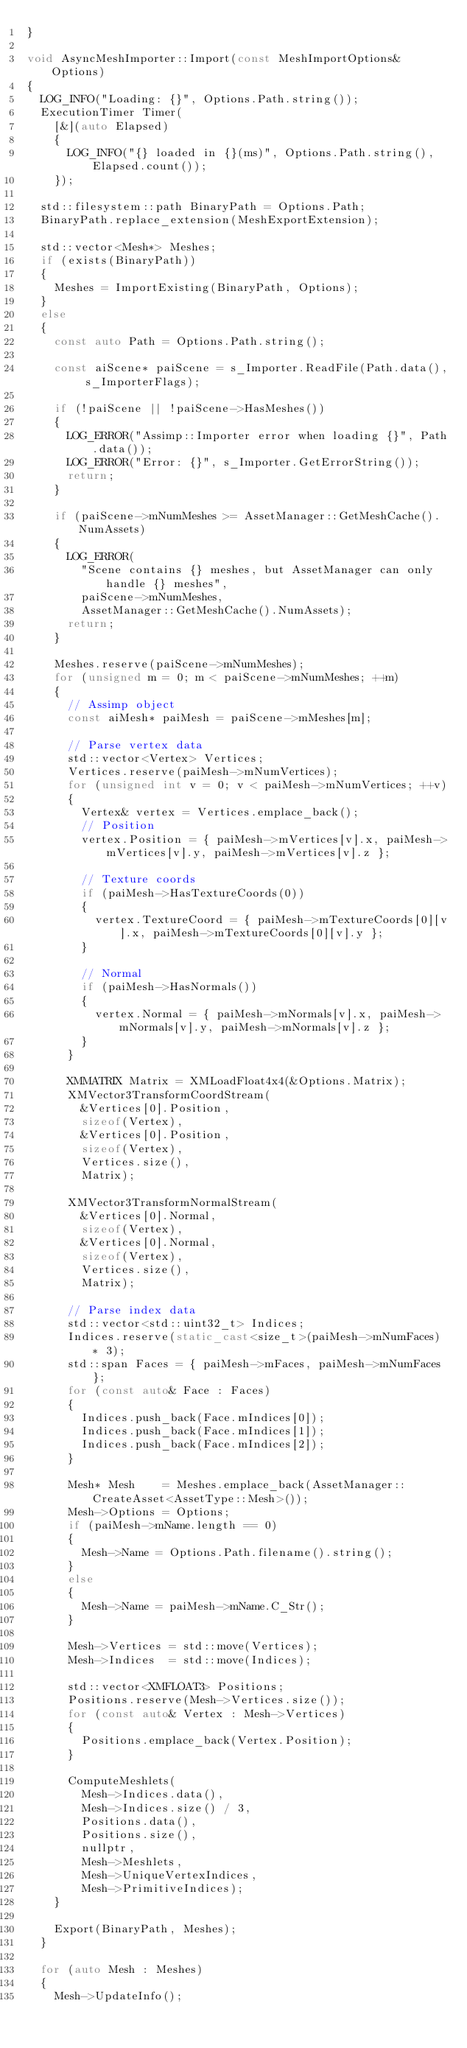<code> <loc_0><loc_0><loc_500><loc_500><_C++_>}

void AsyncMeshImporter::Import(const MeshImportOptions& Options)
{
	LOG_INFO("Loading: {}", Options.Path.string());
	ExecutionTimer Timer(
		[&](auto Elapsed)
		{
			LOG_INFO("{} loaded in {}(ms)", Options.Path.string(), Elapsed.count());
		});

	std::filesystem::path BinaryPath = Options.Path;
	BinaryPath.replace_extension(MeshExportExtension);

	std::vector<Mesh*> Meshes;
	if (exists(BinaryPath))
	{
		Meshes = ImportExisting(BinaryPath, Options);
	}
	else
	{
		const auto Path = Options.Path.string();

		const aiScene* paiScene = s_Importer.ReadFile(Path.data(), s_ImporterFlags);

		if (!paiScene || !paiScene->HasMeshes())
		{
			LOG_ERROR("Assimp::Importer error when loading {}", Path.data());
			LOG_ERROR("Error: {}", s_Importer.GetErrorString());
			return;
		}

		if (paiScene->mNumMeshes >= AssetManager::GetMeshCache().NumAssets)
		{
			LOG_ERROR(
				"Scene contains {} meshes, but AssetManager can only handle {} meshes",
				paiScene->mNumMeshes,
				AssetManager::GetMeshCache().NumAssets);
			return;
		}

		Meshes.reserve(paiScene->mNumMeshes);
		for (unsigned m = 0; m < paiScene->mNumMeshes; ++m)
		{
			// Assimp object
			const aiMesh* paiMesh = paiScene->mMeshes[m];

			// Parse vertex data
			std::vector<Vertex> Vertices;
			Vertices.reserve(paiMesh->mNumVertices);
			for (unsigned int v = 0; v < paiMesh->mNumVertices; ++v)
			{
				Vertex& vertex = Vertices.emplace_back();
				// Position
				vertex.Position = { paiMesh->mVertices[v].x, paiMesh->mVertices[v].y, paiMesh->mVertices[v].z };

				// Texture coords
				if (paiMesh->HasTextureCoords(0))
				{
					vertex.TextureCoord = { paiMesh->mTextureCoords[0][v].x, paiMesh->mTextureCoords[0][v].y };
				}

				// Normal
				if (paiMesh->HasNormals())
				{
					vertex.Normal = { paiMesh->mNormals[v].x, paiMesh->mNormals[v].y, paiMesh->mNormals[v].z };
				}
			}

			XMMATRIX Matrix = XMLoadFloat4x4(&Options.Matrix);
			XMVector3TransformCoordStream(
				&Vertices[0].Position,
				sizeof(Vertex),
				&Vertices[0].Position,
				sizeof(Vertex),
				Vertices.size(),
				Matrix);

			XMVector3TransformNormalStream(
				&Vertices[0].Normal,
				sizeof(Vertex),
				&Vertices[0].Normal,
				sizeof(Vertex),
				Vertices.size(),
				Matrix);

			// Parse index data
			std::vector<std::uint32_t> Indices;
			Indices.reserve(static_cast<size_t>(paiMesh->mNumFaces) * 3);
			std::span Faces = { paiMesh->mFaces, paiMesh->mNumFaces };
			for (const auto& Face : Faces)
			{
				Indices.push_back(Face.mIndices[0]);
				Indices.push_back(Face.mIndices[1]);
				Indices.push_back(Face.mIndices[2]);
			}

			Mesh* Mesh	  = Meshes.emplace_back(AssetManager::CreateAsset<AssetType::Mesh>());
			Mesh->Options = Options;
			if (paiMesh->mName.length == 0)
			{
				Mesh->Name = Options.Path.filename().string();
			}
			else
			{
				Mesh->Name = paiMesh->mName.C_Str();
			}

			Mesh->Vertices = std::move(Vertices);
			Mesh->Indices  = std::move(Indices);

			std::vector<XMFLOAT3> Positions;
			Positions.reserve(Mesh->Vertices.size());
			for (const auto& Vertex : Mesh->Vertices)
			{
				Positions.emplace_back(Vertex.Position);
			}

			ComputeMeshlets(
				Mesh->Indices.data(),
				Mesh->Indices.size() / 3,
				Positions.data(),
				Positions.size(),
				nullptr,
				Mesh->Meshlets,
				Mesh->UniqueVertexIndices,
				Mesh->PrimitiveIndices);
		}

		Export(BinaryPath, Meshes);
	}

	for (auto Mesh : Meshes)
	{
		Mesh->UpdateInfo();</code> 